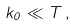<formula> <loc_0><loc_0><loc_500><loc_500>k _ { 0 } \ll T \, ,</formula> 